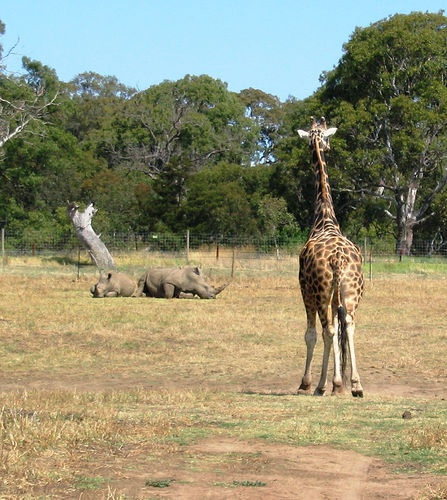Describe the objects in this image and their specific colors. I can see a giraffe in lightblue, black, and gray tones in this image. 